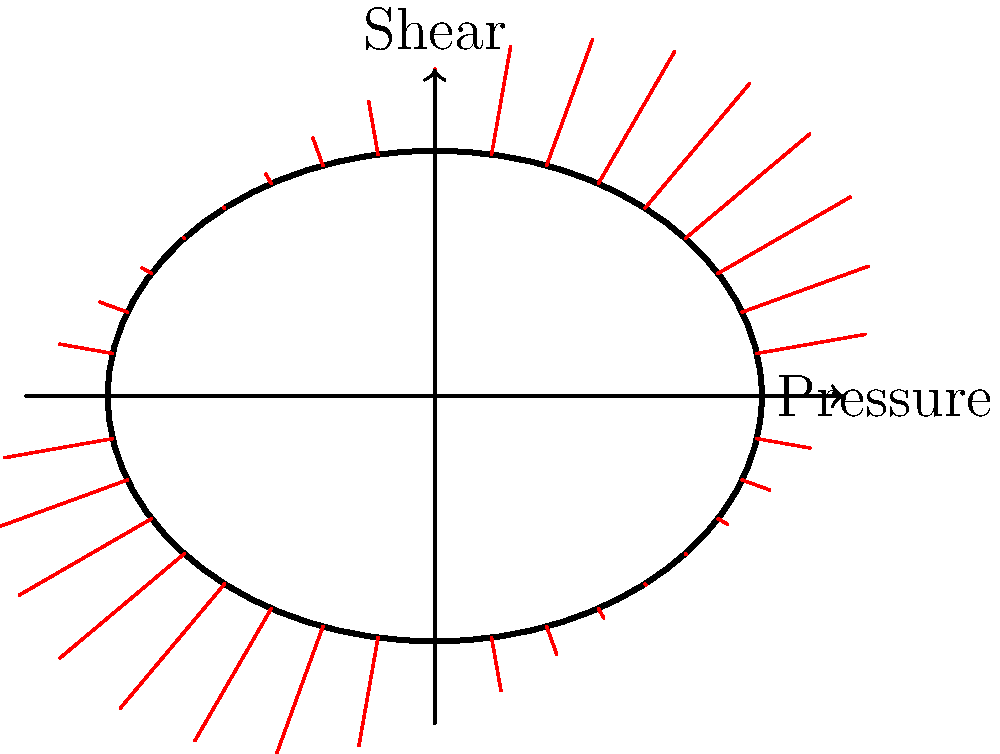In the given stress distribution diagram of a fuselage cross-section, what can be inferred about the primary load condition and its impact on the structure? Provide a quantitative assessment of the maximum stress location and magnitude relative to the minimum stress. To analyze the stress distribution pattern and infer the primary load condition:

1. Observe the stress distribution: The diagram shows varying stress magnitudes around the fuselage cross-section, represented by red lines of different lengths.

2. Identify the pattern: The stress distribution follows a sinusoidal pattern, with four distinct peaks and troughs.

3. Locate maximum stress: The maximum stress occurs at approximately 45°, 135°, 225°, and 315° angles from the horizontal axis.

4. Locate minimum stress: The minimum stress is observed at 0°, 90°, 180°, and 270° angles.

5. Interpret the load condition: This pattern suggests a combination of internal pressure and shear loading. The internal pressure creates a uniform stress distribution, while the shear loading introduces the sinusoidal variation.

6. Quantify the stress variation:
   - Maximum stress magnitude: Approximately 2 units
   - Minimum stress magnitude: Approximately 1 unit
   - Relative difference: (2 - 1) / 1 = 100% increase from minimum to maximum

7. Primary load condition: The dominant factor appears to be shear loading, as evidenced by the significant stress variation around the circumference.

8. Impact on structure: The varying stress distribution indicates that certain areas of the fuselage (at 45°, 135°, 225°, and 315°) will experience higher stresses and may require additional reinforcement or monitoring during design and maintenance.
Answer: Combined internal pressure and shear loading, with maximum stress 100% higher than minimum at 45°, 135°, 225°, and 315° angles. 